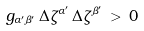Convert formula to latex. <formula><loc_0><loc_0><loc_500><loc_500>g _ { \alpha ^ { \prime } \beta ^ { \prime } } \, \Delta { \zeta } ^ { \alpha ^ { \prime } } \, \Delta { \zeta } ^ { \beta ^ { \prime } } \, > \, 0</formula> 